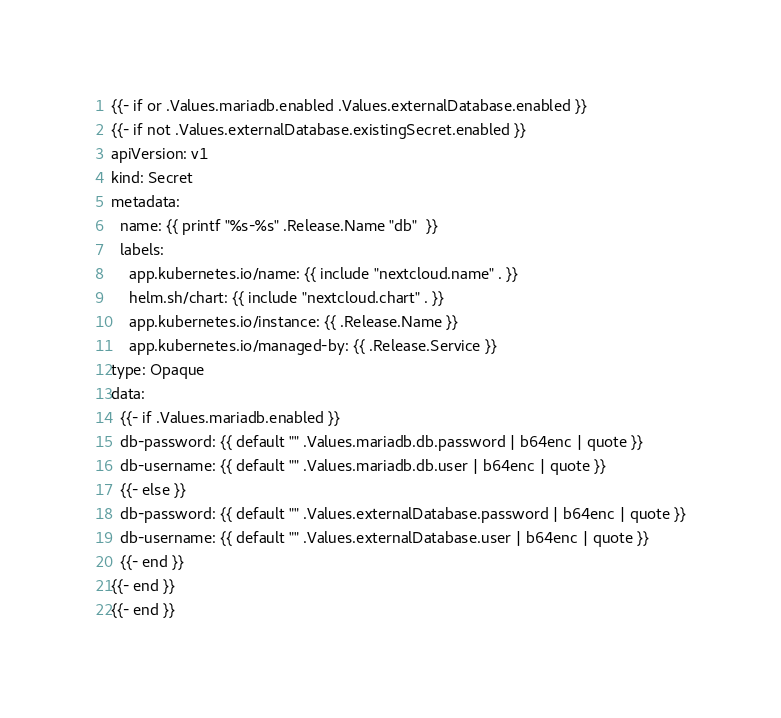Convert code to text. <code><loc_0><loc_0><loc_500><loc_500><_YAML_>{{- if or .Values.mariadb.enabled .Values.externalDatabase.enabled }}
{{- if not .Values.externalDatabase.existingSecret.enabled }}
apiVersion: v1
kind: Secret
metadata:
  name: {{ printf "%s-%s" .Release.Name "db"  }}
  labels:
    app.kubernetes.io/name: {{ include "nextcloud.name" . }}
    helm.sh/chart: {{ include "nextcloud.chart" . }}
    app.kubernetes.io/instance: {{ .Release.Name }}
    app.kubernetes.io/managed-by: {{ .Release.Service }}
type: Opaque
data:
  {{- if .Values.mariadb.enabled }}
  db-password: {{ default "" .Values.mariadb.db.password | b64enc | quote }}
  db-username: {{ default "" .Values.mariadb.db.user | b64enc | quote }}
  {{- else }}
  db-password: {{ default "" .Values.externalDatabase.password | b64enc | quote }}
  db-username: {{ default "" .Values.externalDatabase.user | b64enc | quote }}
  {{- end }}
{{- end }}
{{- end }}</code> 